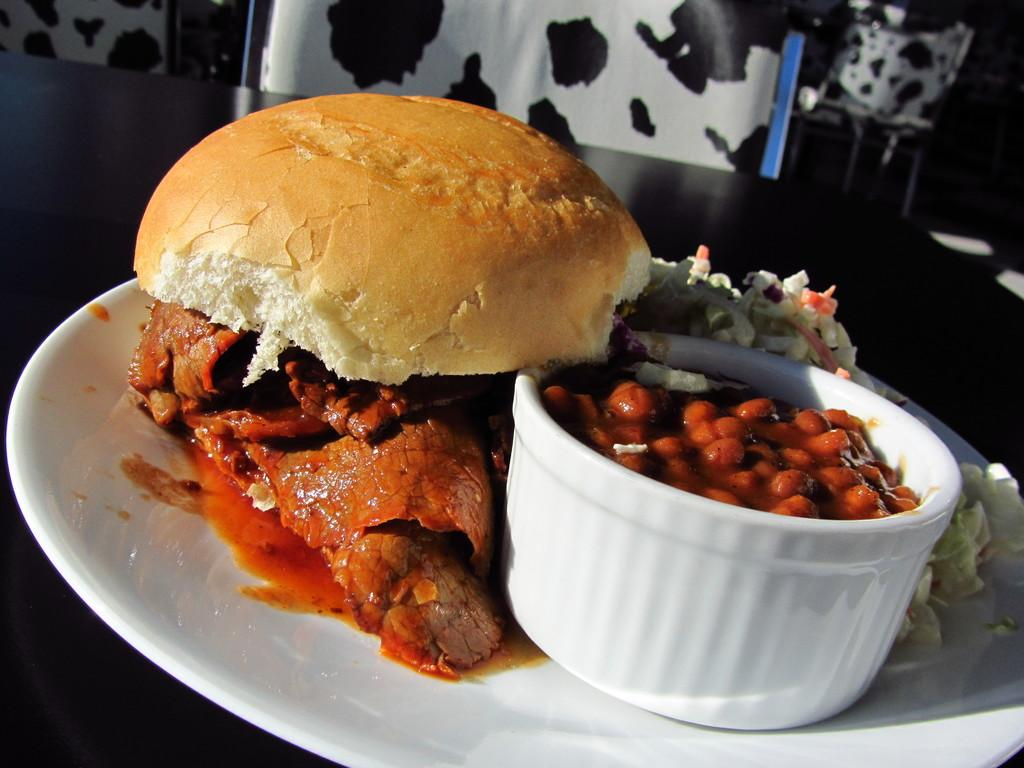What is on the plate that is visible in the image? There is a plate with food items in the image. What type of container is on the plate? There is a bowl on the plate. Where is the plate and bowl located in the image? The plate and bowl are placed on a table. What can be seen in the background of the image? There are chairs present in the background of the image. What type of pies are being served to the father in the image? There is no father or pies present in the image; it only shows a plate with food items and a bowl on a table. 